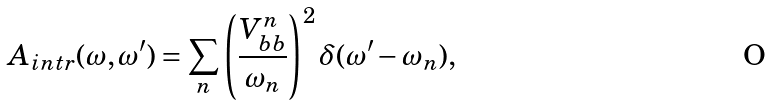<formula> <loc_0><loc_0><loc_500><loc_500>A _ { i n t r } ( \omega , \omega ^ { \prime } ) = \sum _ { n } \left ( \frac { V _ { b b } ^ { n } } { \omega _ { n } } \right ) ^ { 2 } \delta ( \omega ^ { \prime } - \omega _ { n } ) ,</formula> 